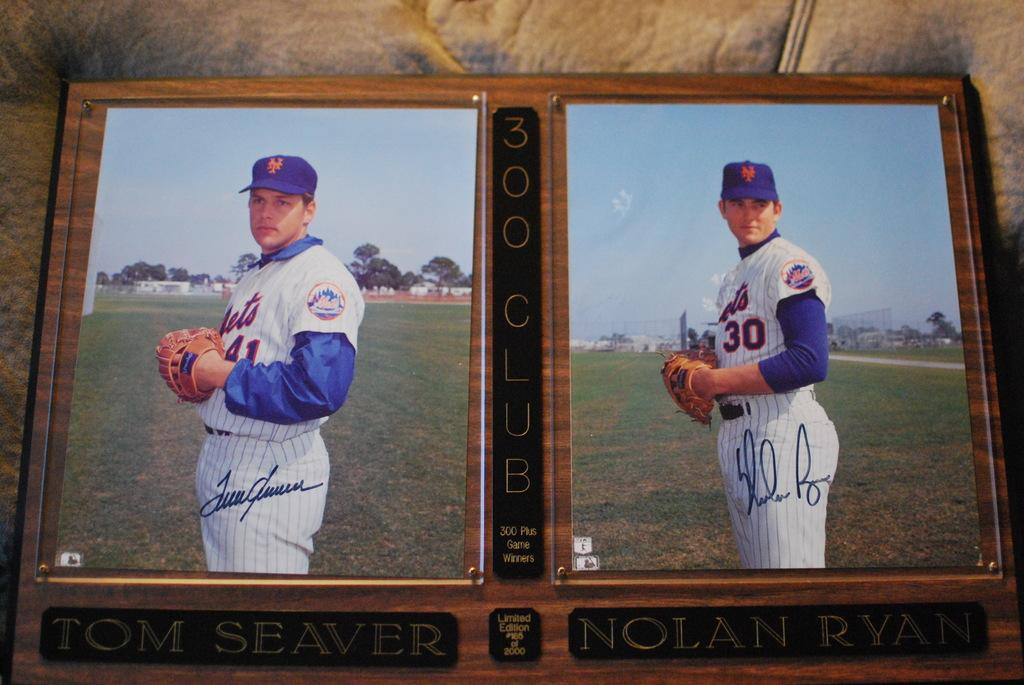<image>
Share a concise interpretation of the image provided. Two pictures of baseball players and one has the number 30 on his jersey. 